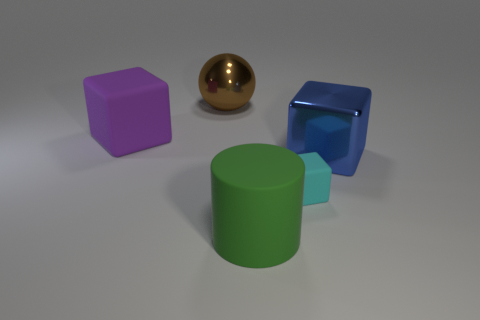Add 1 large purple rubber cubes. How many objects exist? 6 Subtract all cylinders. How many objects are left? 4 Subtract 1 cyan cubes. How many objects are left? 4 Subtract all blue metal cubes. Subtract all rubber objects. How many objects are left? 1 Add 4 rubber objects. How many rubber objects are left? 7 Add 5 large matte things. How many large matte things exist? 7 